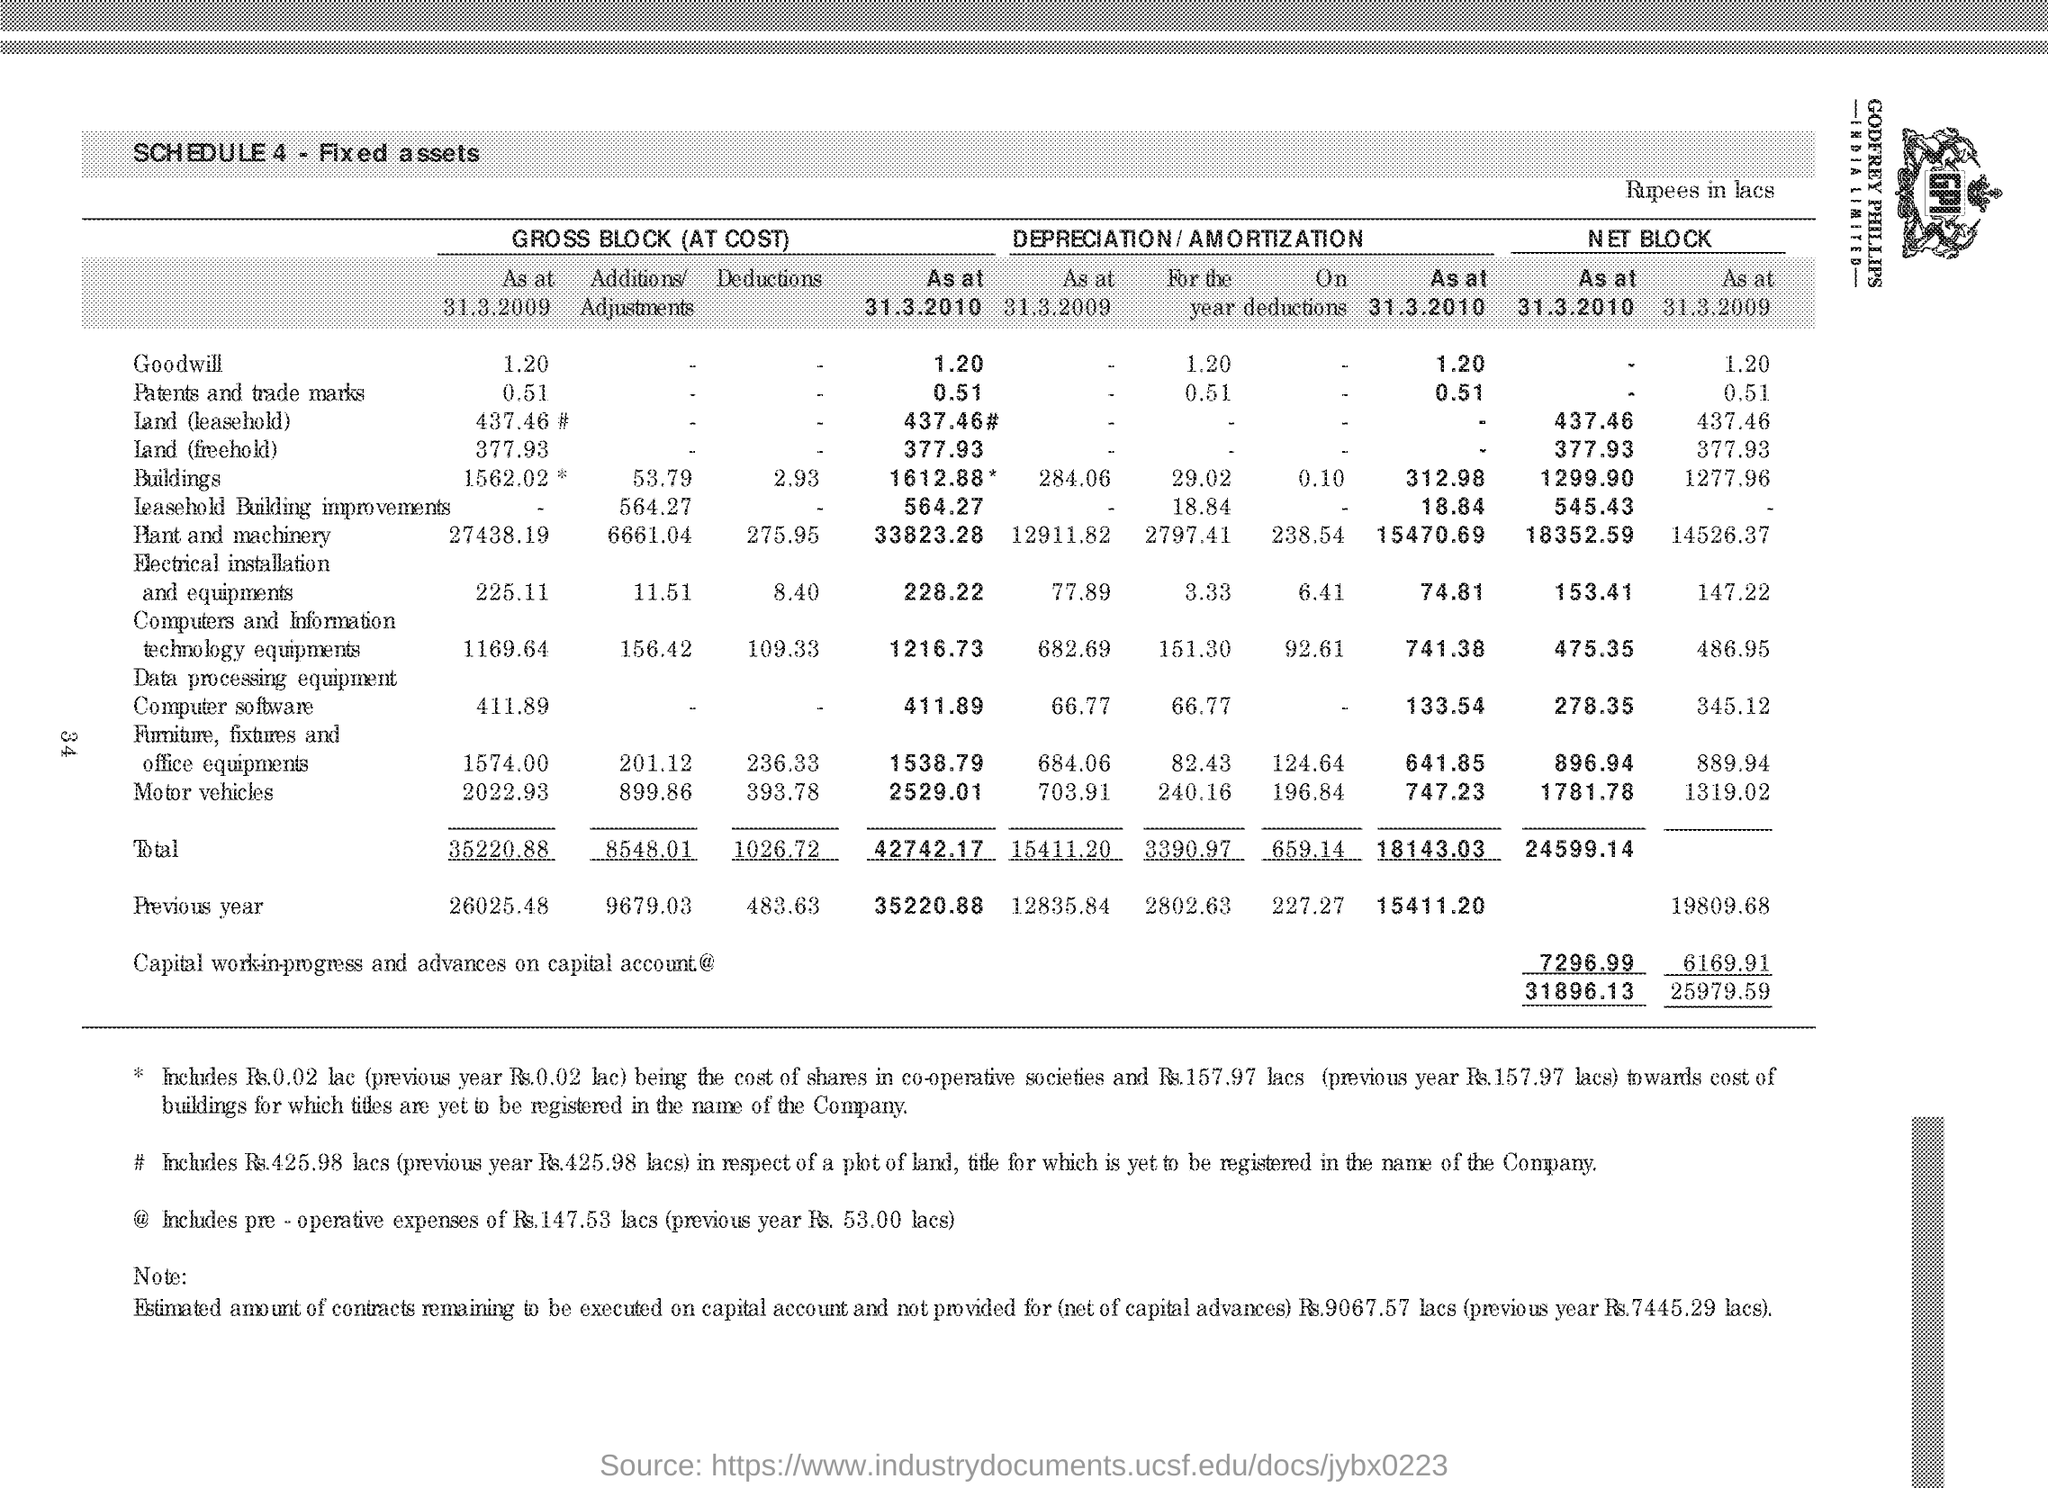What SCHEDULE 4 highlights?
Offer a very short reply. Fixed assets. How much is the Total cost of 'Gross Block' at 31.3.2009 ?
Offer a terse response. 35220.88. How much is the Total cost of 'Gross Block' at 31.3.2010 ?
Keep it short and to the point. 42742.17. Which year has higher 'Gross Block' total when '31.3.2009' and '31.3.2010' are compared?
Provide a succinct answer. 31.3.2010. What is the Net Block of 'Goodwill' at 31.3.2009?
Provide a succinct answer. 1.20. How much is the 'GROSS BLOCK Deductions' for "Motor vehicles' ?
Provide a short and direct response. 393.78. What was the previous year 'Gross Block Deductions" ?
Offer a very short reply. 483.63. What is the third 'fixed asset' in the table from the top?
Make the answer very short. Land (leasehold). 